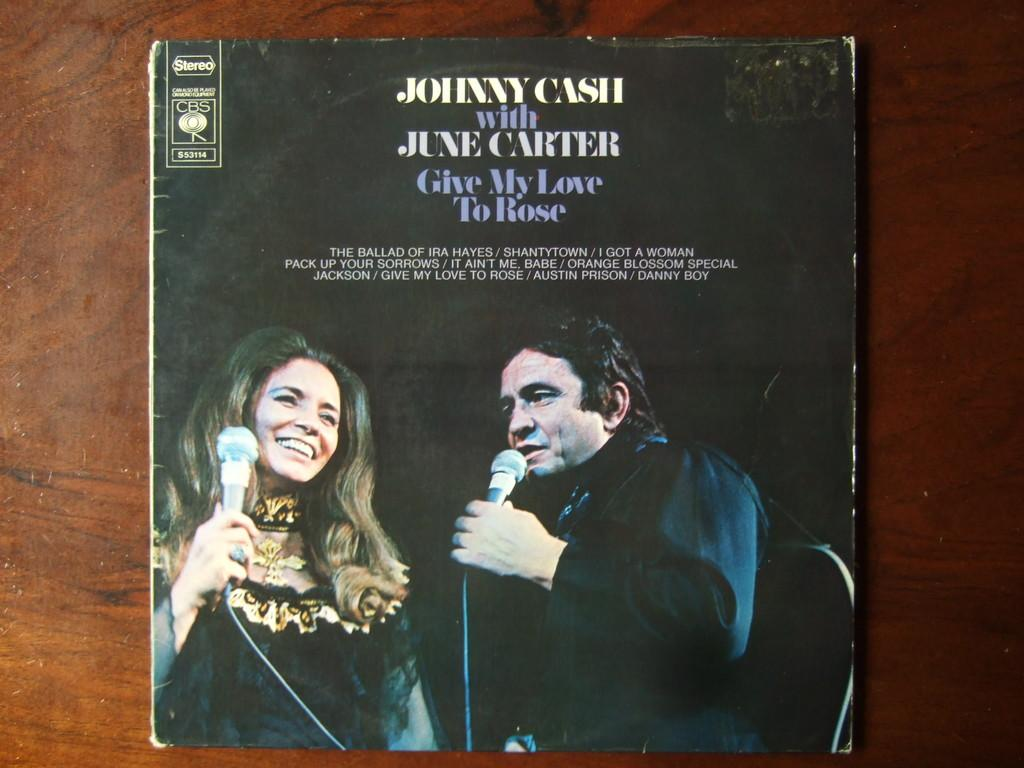<image>
Give a short and clear explanation of the subsequent image. A Johnny Cash record album features June Carter Cash. 